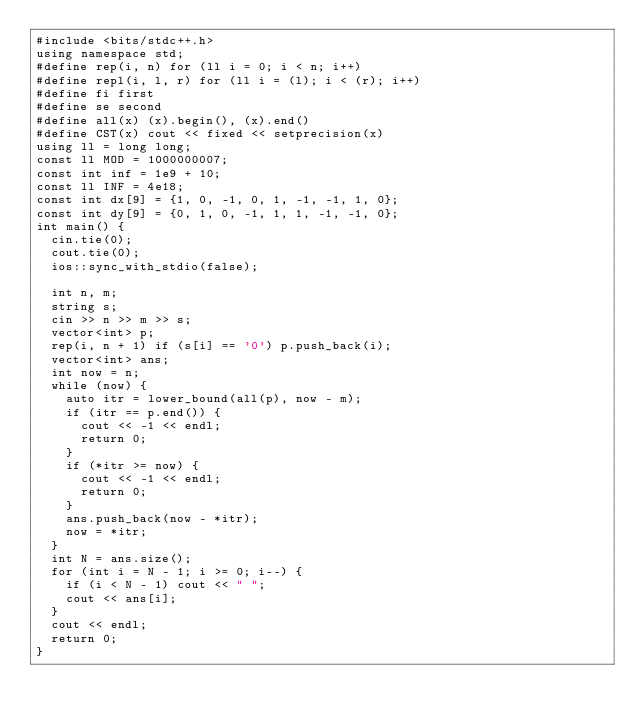<code> <loc_0><loc_0><loc_500><loc_500><_C++_>#include <bits/stdc++.h>
using namespace std;
#define rep(i, n) for (ll i = 0; i < n; i++)
#define repl(i, l, r) for (ll i = (l); i < (r); i++)
#define fi first
#define se second
#define all(x) (x).begin(), (x).end()
#define CST(x) cout << fixed << setprecision(x)
using ll = long long;
const ll MOD = 1000000007;
const int inf = 1e9 + 10;
const ll INF = 4e18;
const int dx[9] = {1, 0, -1, 0, 1, -1, -1, 1, 0};
const int dy[9] = {0, 1, 0, -1, 1, 1, -1, -1, 0};
int main() {
	cin.tie(0);
	cout.tie(0);
	ios::sync_with_stdio(false);

	int n, m;
	string s;
	cin >> n >> m >> s;
	vector<int> p;
	rep(i, n + 1) if (s[i] == '0') p.push_back(i);
	vector<int> ans;
	int now = n;
	while (now) {
		auto itr = lower_bound(all(p), now - m);
		if (itr == p.end()) {
			cout << -1 << endl;
			return 0;
		}
		if (*itr >= now) {
			cout << -1 << endl;
			return 0;
		}
		ans.push_back(now - *itr);
		now = *itr;
	}
	int N = ans.size();
	for (int i = N - 1; i >= 0; i--) {
		if (i < N - 1) cout << " ";
		cout << ans[i];
	}
	cout << endl;
	return 0;
}</code> 